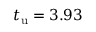Convert formula to latex. <formula><loc_0><loc_0><loc_500><loc_500>t _ { u } = 3 . 9 3</formula> 